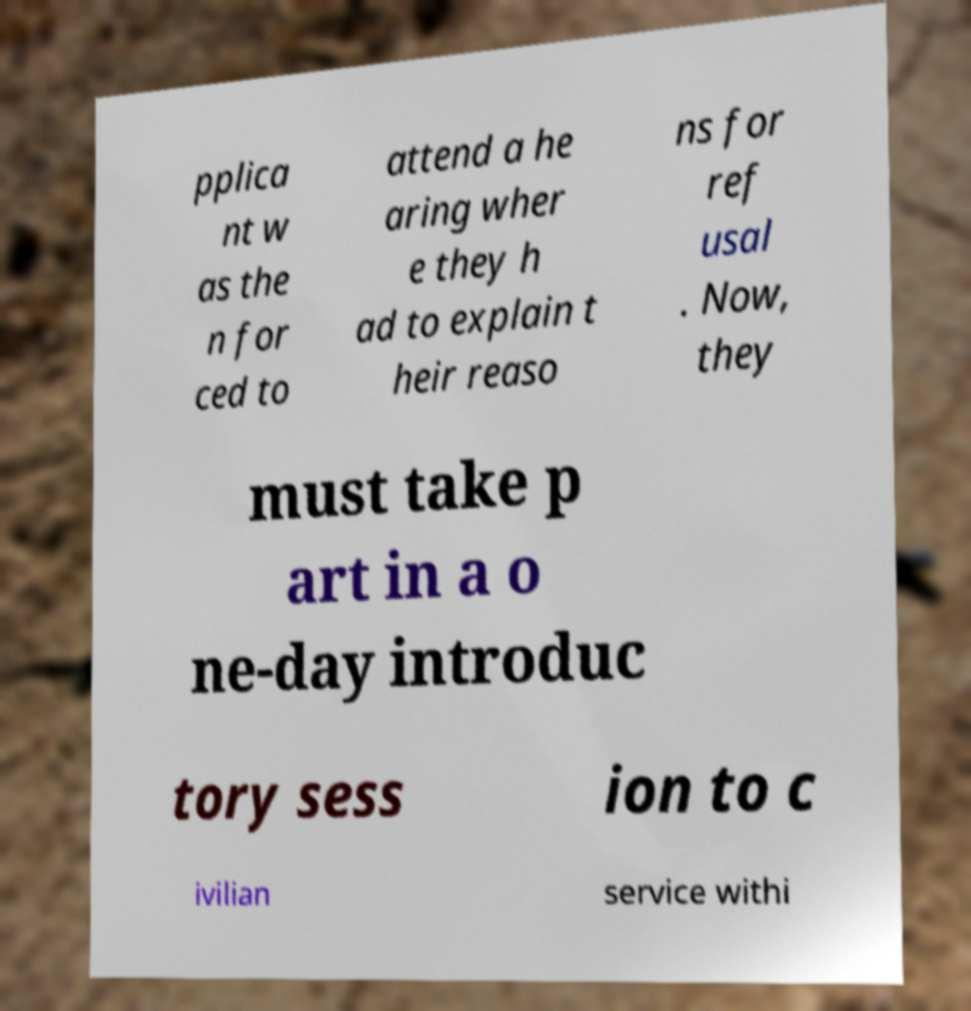I need the written content from this picture converted into text. Can you do that? pplica nt w as the n for ced to attend a he aring wher e they h ad to explain t heir reaso ns for ref usal . Now, they must take p art in a o ne-day introduc tory sess ion to c ivilian service withi 